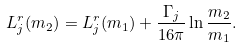Convert formula to latex. <formula><loc_0><loc_0><loc_500><loc_500>L ^ { r } _ { j } ( m _ { 2 } ) = L ^ { r } _ { j } ( m _ { 1 } ) + \frac { \Gamma _ { j } } { 1 6 \pi } \ln \frac { m _ { 2 } } { m _ { 1 } } .</formula> 